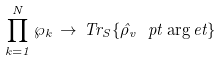<formula> <loc_0><loc_0><loc_500><loc_500>\prod _ { k = 1 } ^ { N } \wp _ { k } \, \rightarrow \, T r _ { S } \{ \hat { \rho } _ { v } \ p t \arg e t \}</formula> 